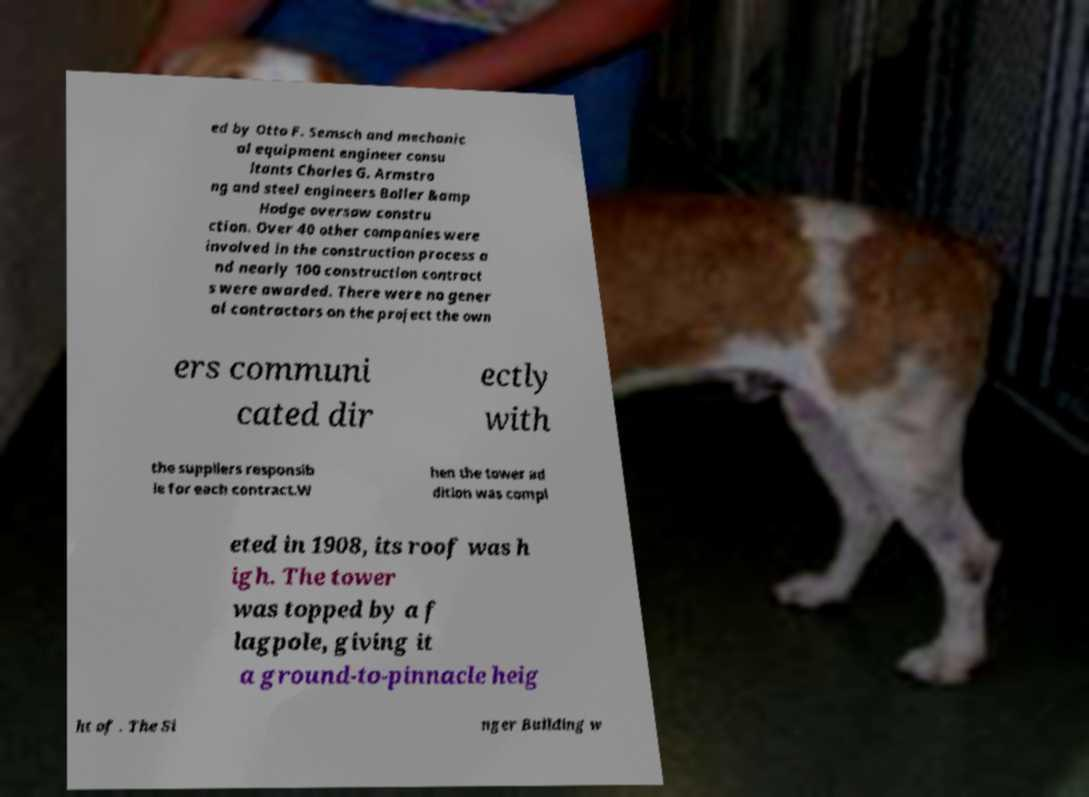Can you accurately transcribe the text from the provided image for me? ed by Otto F. Semsch and mechanic al equipment engineer consu ltants Charles G. Armstro ng and steel engineers Boller &amp Hodge oversaw constru ction. Over 40 other companies were involved in the construction process a nd nearly 100 construction contract s were awarded. There were no gener al contractors on the project the own ers communi cated dir ectly with the suppliers responsib le for each contract.W hen the tower ad dition was compl eted in 1908, its roof was h igh. The tower was topped by a f lagpole, giving it a ground-to-pinnacle heig ht of . The Si nger Building w 